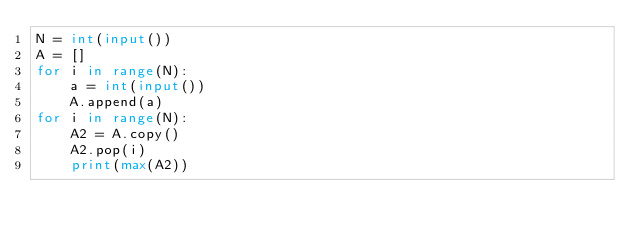<code> <loc_0><loc_0><loc_500><loc_500><_Python_>N = int(input())
A = []
for i in range(N):
    a = int(input())
    A.append(a)
for i in range(N):
    A2 = A.copy()
    A2.pop(i)
    print(max(A2))
    </code> 